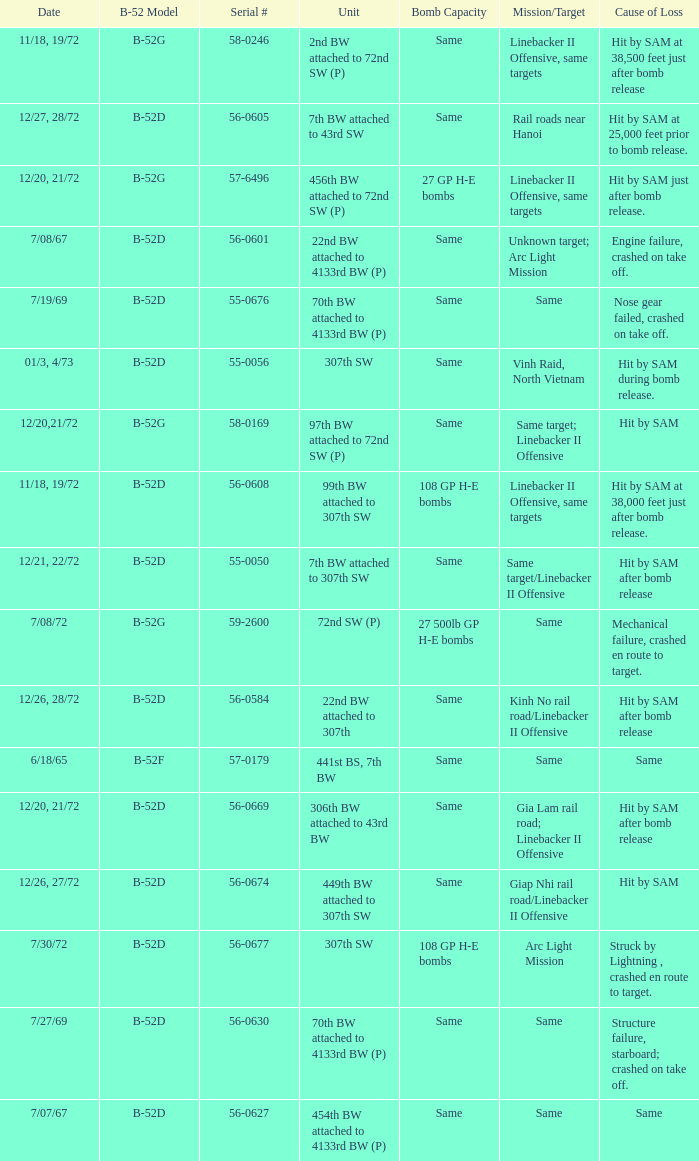When hit by sam at 38,500 feet just after bomb release was the cause of loss what is the mission/target? Linebacker II Offensive, same targets. 